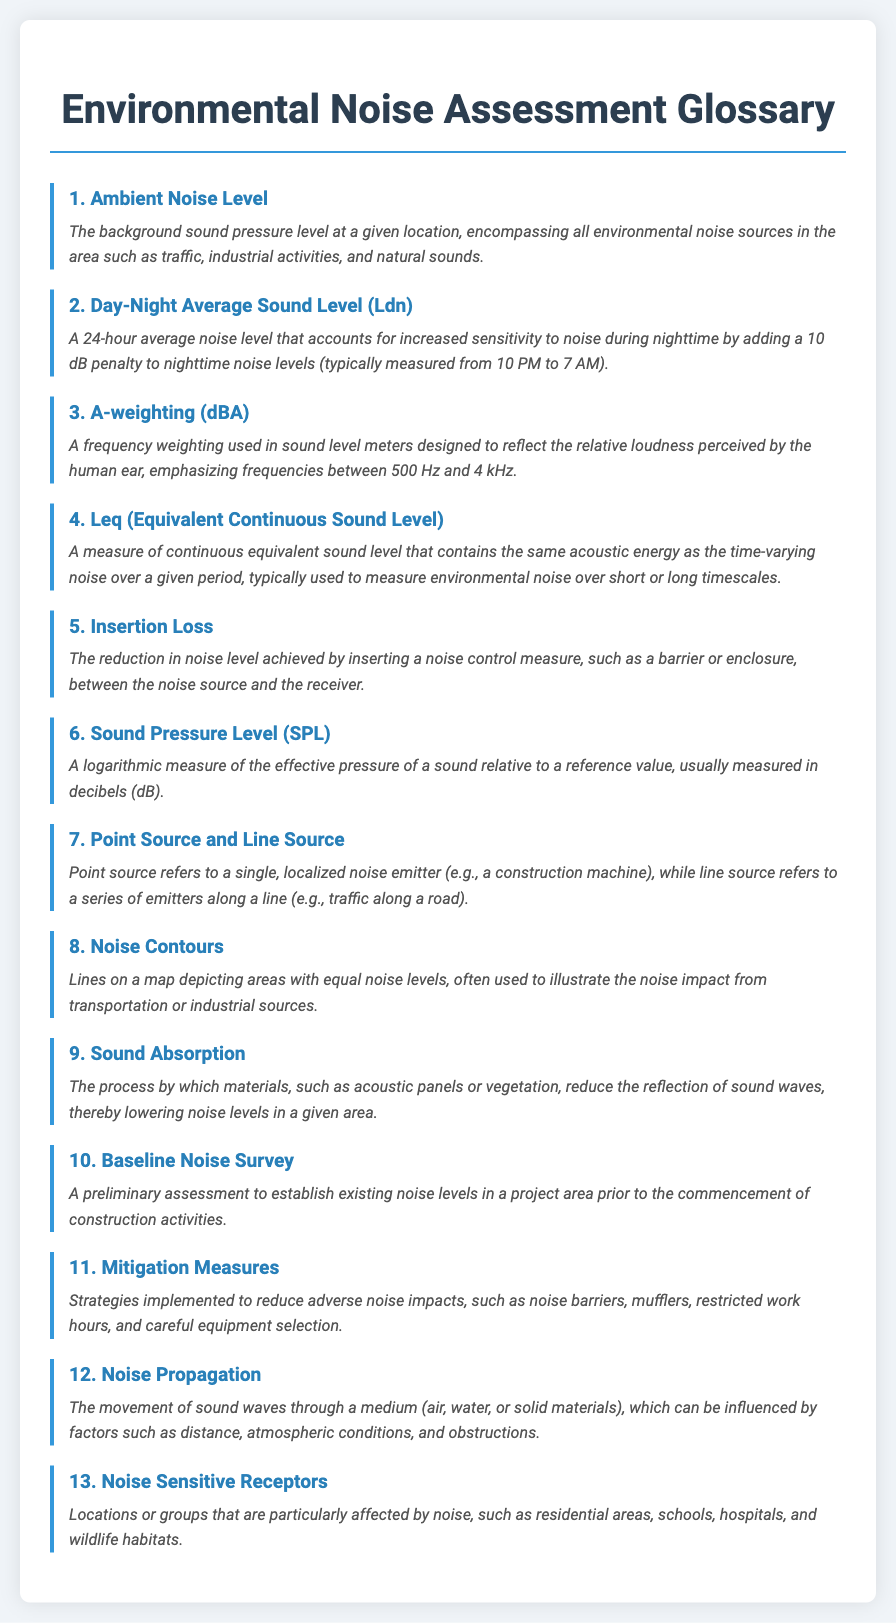What is the first term in the glossary? The first term listed in the glossary is at the top of the document and is "Ambient Noise Level."
Answer: Ambient Noise Level What is the penalty added to nighttime noise levels? The document states that a 10 dB penalty is added to nighttime noise levels for the Day-Night Average Sound Level.
Answer: 10 dB What does SPL stand for? SPL is defined in the glossary as "Sound Pressure Level."
Answer: Sound Pressure Level How many noise-sensitive receptors are mentioned? The glossary suggests that there are various types of noise-sensitive receptors, but the exact count is not specified; it mentions "residential areas, schools, hospitals, and wildlife habitats."
Answer: four Which measurement accounts for environmental noise over varying periods? Leq (Equivalent Continuous Sound Level) is the measure mentioned for evaluating noise over varying periods.
Answer: Leq What type of noise does Insertion Loss refer to? Insertion Loss refers to the reduction in noise level achieved by a noise control measure like a barrier.
Answer: noise level What is the purpose of a Baseline Noise Survey? The Baseline Noise Survey is described as a preliminary assessment to establish existing noise levels before construction activities.
Answer: establish existing noise levels What are the strategies included in Mitigation Measures? The glossary explains that strategies such as noise barriers, mufflers, restricted work hours, and careful equipment selection are included in Mitigation Measures.
Answer: noise barriers, mufflers, restricted work hours, careful equipment selection 